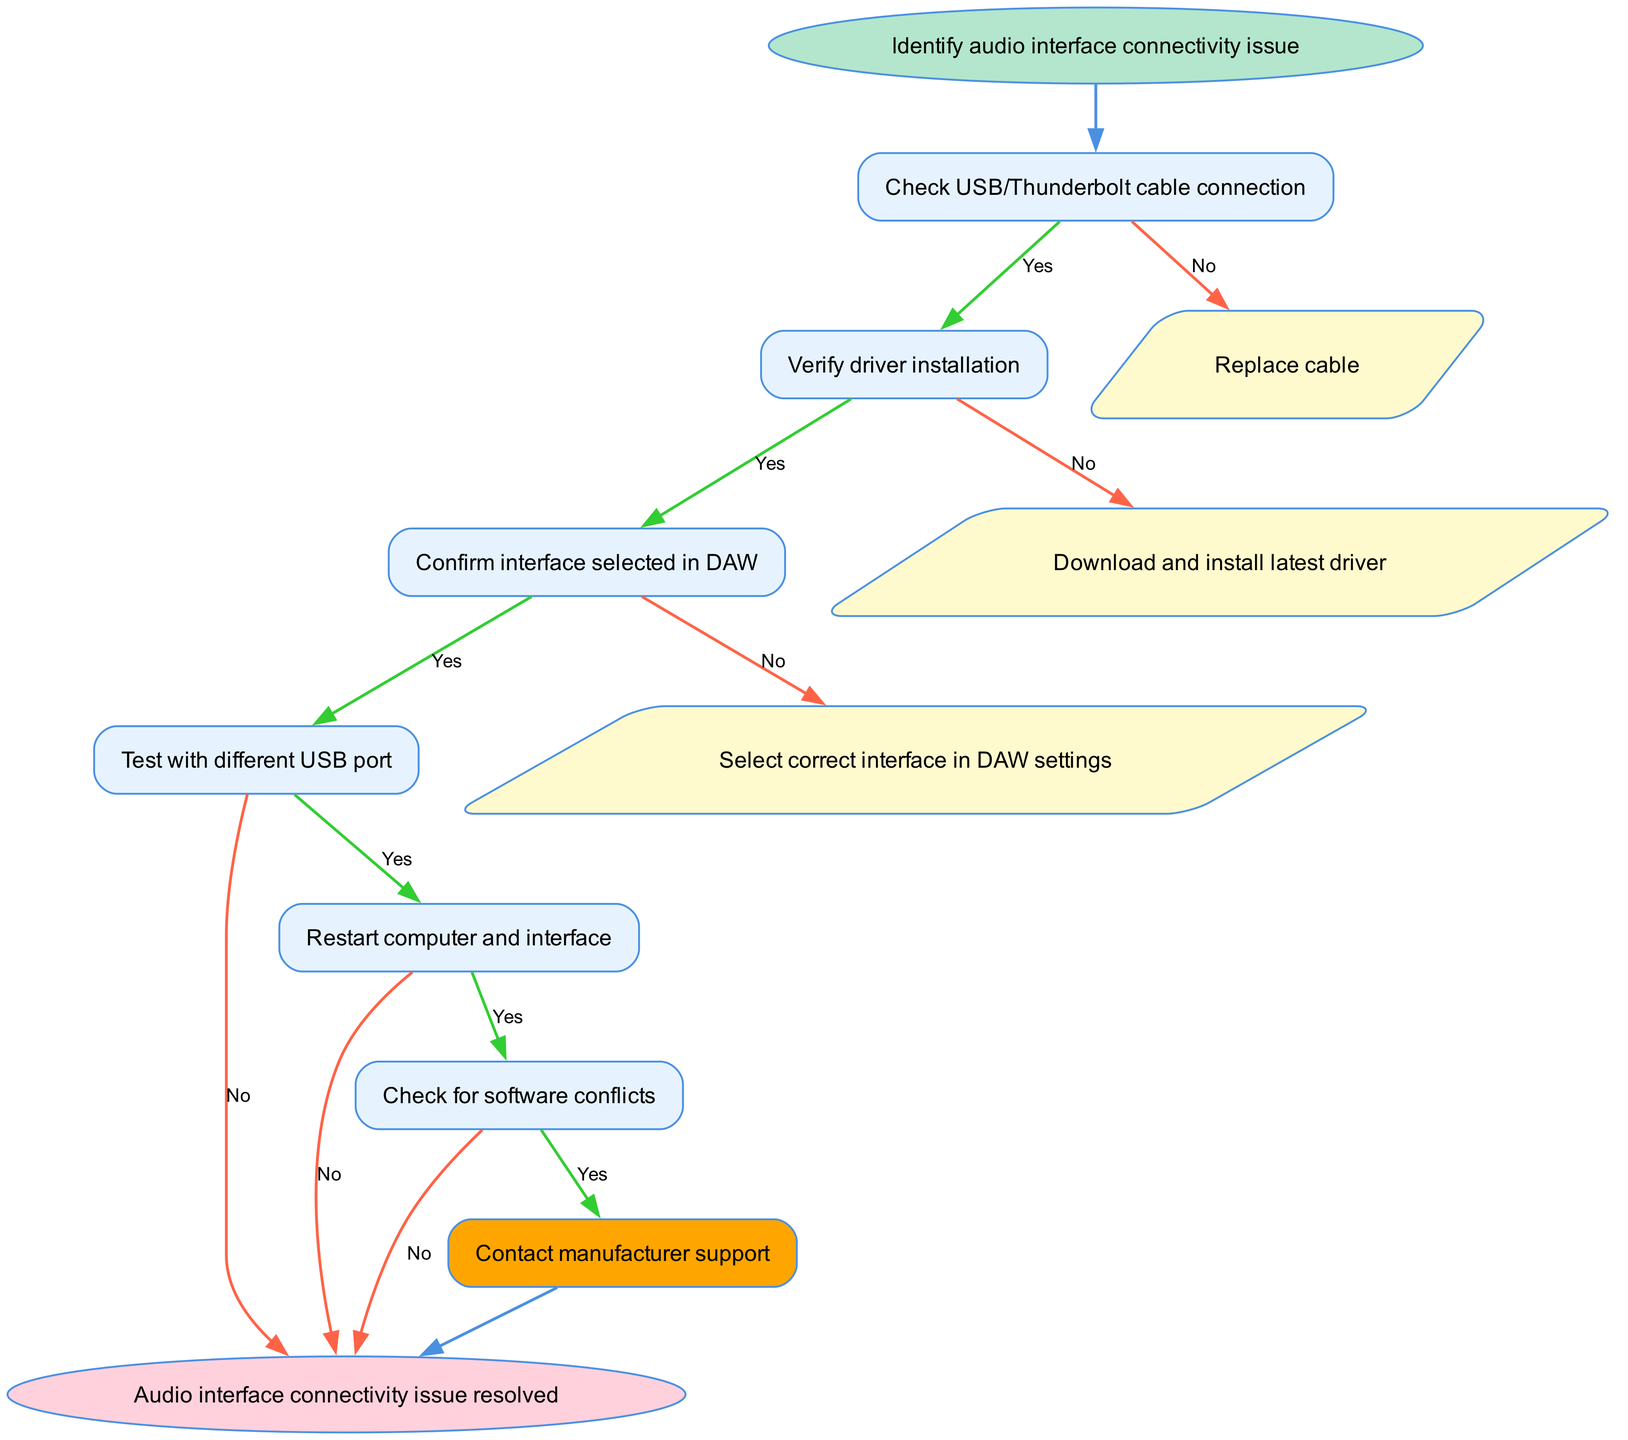What is the starting point of the flow chart? The starting point of the flow chart is indicated by the "Identify audio interface connectivity issue" label in the start node.
Answer: Identify audio interface connectivity issue How many steps are in the diagram? The diagram consists of 6 steps, each represented by a numbered node from 1 to 6.
Answer: 6 What is the action taken if the USB/Thunderbolt cable connection check is negative? If the cable connection check is negative, the action indicated is to "Replace cable," which is specified as the output from node 1 when the answer is "No."
Answer: Replace cable Which action follows after confirming the interface is selected in the DAW? After confirming the interface is selected in the DAW, the next action is to "Test with different USB port," as shown in the flow from node 3 to node 4.
Answer: Test with different USB port What happens if software conflicts are detected? If software conflicts are detected, the flow directs to "Contact manufacturer support," which is represented as an alternative action from node 6 for the "Yes" response.
Answer: Contact manufacturer support What does the flow indicate as the final outcome if all checks are resolved? The flow indicates that if all checks are resolved, the final outcome is "Audio interface connectivity issue resolved," marked by the end node.
Answer: Audio interface connectivity issue resolved What would be the next step after testing with a different USB port if the test is successful? If testing with a different USB port resolves the issue, the flow indicates that the issue is considered resolved and goes directly to the end node.
Answer: Issue resolved What is the relationship between checking driver installation and confirming the interface selected in DAW? The relationship is sequential; confirming the driver installation takes you to the next step of confirming the interface selection in the DAW, indicating a flow from step 2 to step 3 if the answer is "Yes."
Answer: Sequential relationship What does the flow chart suggest if the driver installation verification fails? If the driver installation verification fails, the chart suggests to "Download and install latest driver," directing to an action node specifically for that case.
Answer: Download and install latest driver 